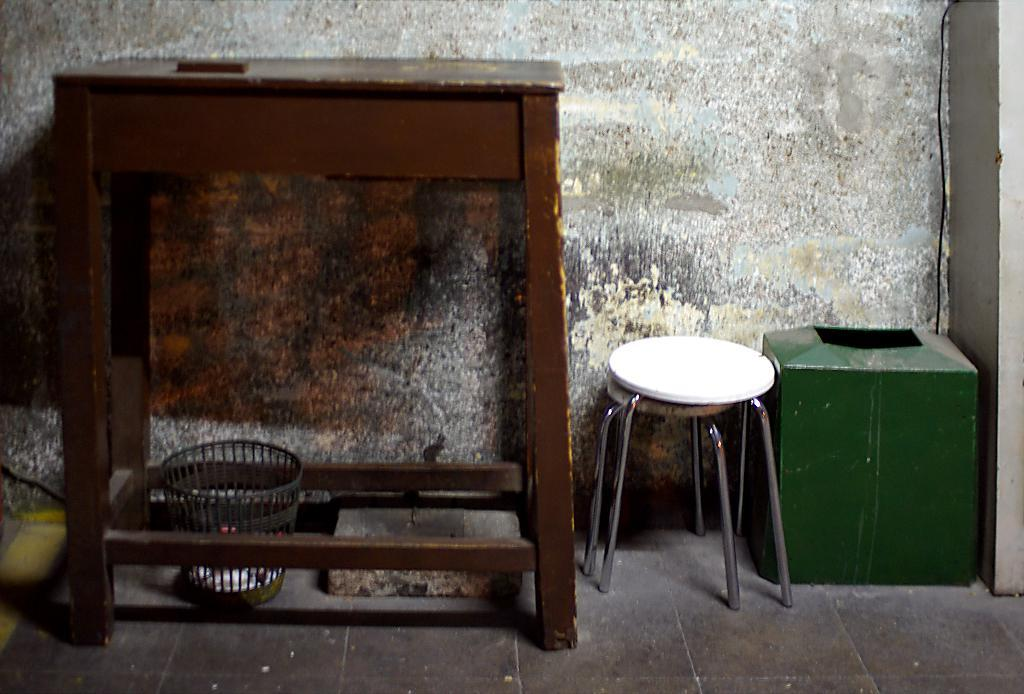What type of furniture is present in the image? There is a table and a stool in the image. What is located on the floor in the image? There is a stool on the floor in the image. What type of container is present in the image? There is a basket in the image. What can be seen inside the basket? The objects visible in the image are inside the basket. What is visible in the background of the image? There is a wall in the background of the image. What type of crown is placed on top of the table in the image? There is no crown present in the image; it only features a table, stool, basket, and objects. 